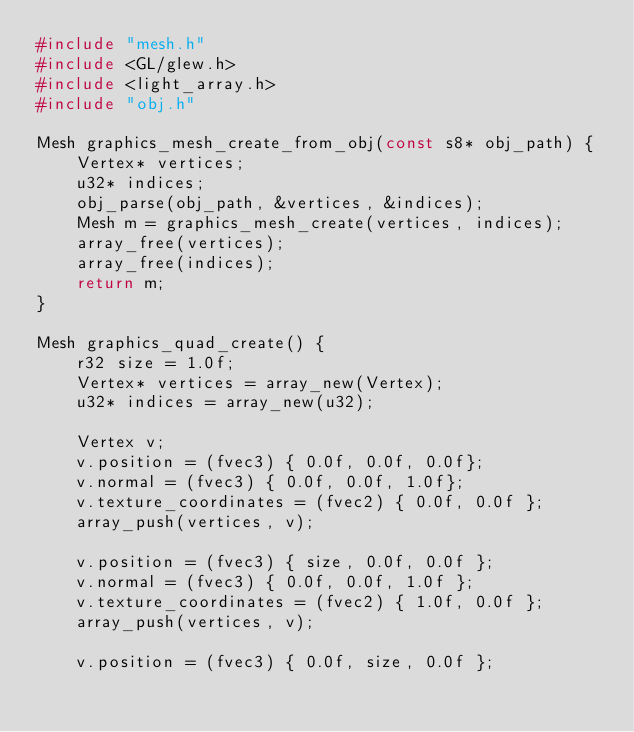<code> <loc_0><loc_0><loc_500><loc_500><_C++_>#include "mesh.h"
#include <GL/glew.h>
#include <light_array.h>
#include "obj.h"

Mesh graphics_mesh_create_from_obj(const s8* obj_path) {
	Vertex* vertices;
	u32* indices;
	obj_parse(obj_path, &vertices, &indices);
	Mesh m = graphics_mesh_create(vertices, indices);
	array_free(vertices);
	array_free(indices);
	return m;
}

Mesh graphics_quad_create() {
	r32 size = 1.0f;
	Vertex* vertices = array_new(Vertex);
	u32* indices = array_new(u32);

	Vertex v;
	v.position = (fvec3) { 0.0f, 0.0f, 0.0f};
	v.normal = (fvec3) { 0.0f, 0.0f, 1.0f};
	v.texture_coordinates = (fvec2) { 0.0f, 0.0f };
	array_push(vertices, v);

	v.position = (fvec3) { size, 0.0f, 0.0f };
	v.normal = (fvec3) { 0.0f, 0.0f, 1.0f };
	v.texture_coordinates = (fvec2) { 1.0f, 0.0f };
	array_push(vertices, v);

	v.position = (fvec3) { 0.0f, size, 0.0f };</code> 